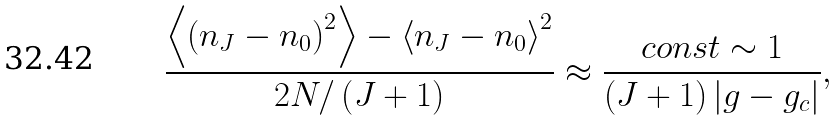Convert formula to latex. <formula><loc_0><loc_0><loc_500><loc_500>\frac { \left < { \left ( n _ { J } - n _ { 0 } \right ) } ^ { 2 } \right > - { \left < n _ { J } - n _ { 0 } \right > } ^ { 2 } } { 2 N / \left ( J + 1 \right ) } \approx \frac { c o n s t \sim 1 } { \left ( J + 1 \right ) \left | g - g _ { c } \right | } ,</formula> 